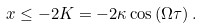<formula> <loc_0><loc_0><loc_500><loc_500>x \leq - 2 K = - 2 \kappa \cos \left ( \Omega \tau \right ) .</formula> 